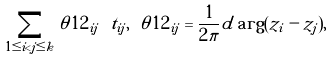<formula> <loc_0><loc_0><loc_500><loc_500>\sum _ { 1 \leq i < j \leq k } \theta ^ { } { 1 } 2 _ { i j } \ t _ { i j } , \ \theta ^ { } { 1 } 2 _ { i j } = \frac { 1 } { 2 \pi } d \arg ( z _ { i } - z _ { j } ) ,</formula> 